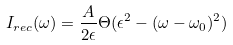Convert formula to latex. <formula><loc_0><loc_0><loc_500><loc_500>I _ { r e c } ( \omega ) = \frac { A } { 2 \epsilon } \Theta ( \epsilon ^ { 2 } - ( \omega - \omega _ { 0 } ) ^ { 2 } )</formula> 